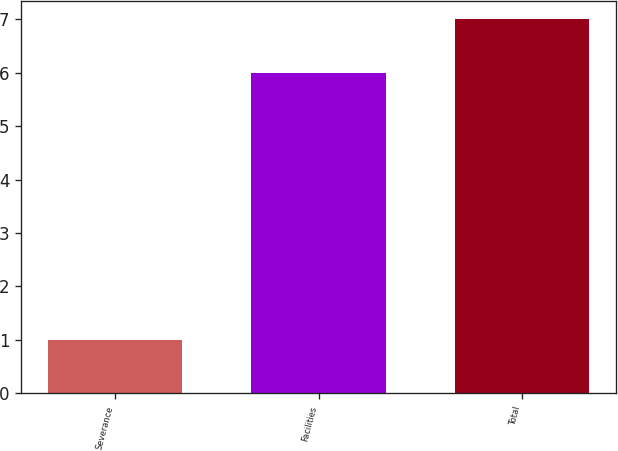Convert chart. <chart><loc_0><loc_0><loc_500><loc_500><bar_chart><fcel>Severance<fcel>Facilities<fcel>Total<nl><fcel>1<fcel>6<fcel>7<nl></chart> 